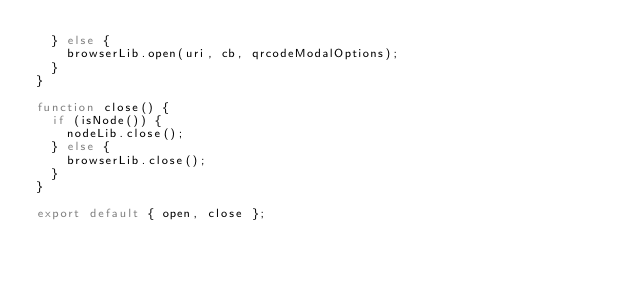Convert code to text. <code><loc_0><loc_0><loc_500><loc_500><_TypeScript_>  } else {
    browserLib.open(uri, cb, qrcodeModalOptions);
  }
}

function close() {
  if (isNode()) {
    nodeLib.close();
  } else {
    browserLib.close();
  }
}

export default { open, close };
</code> 